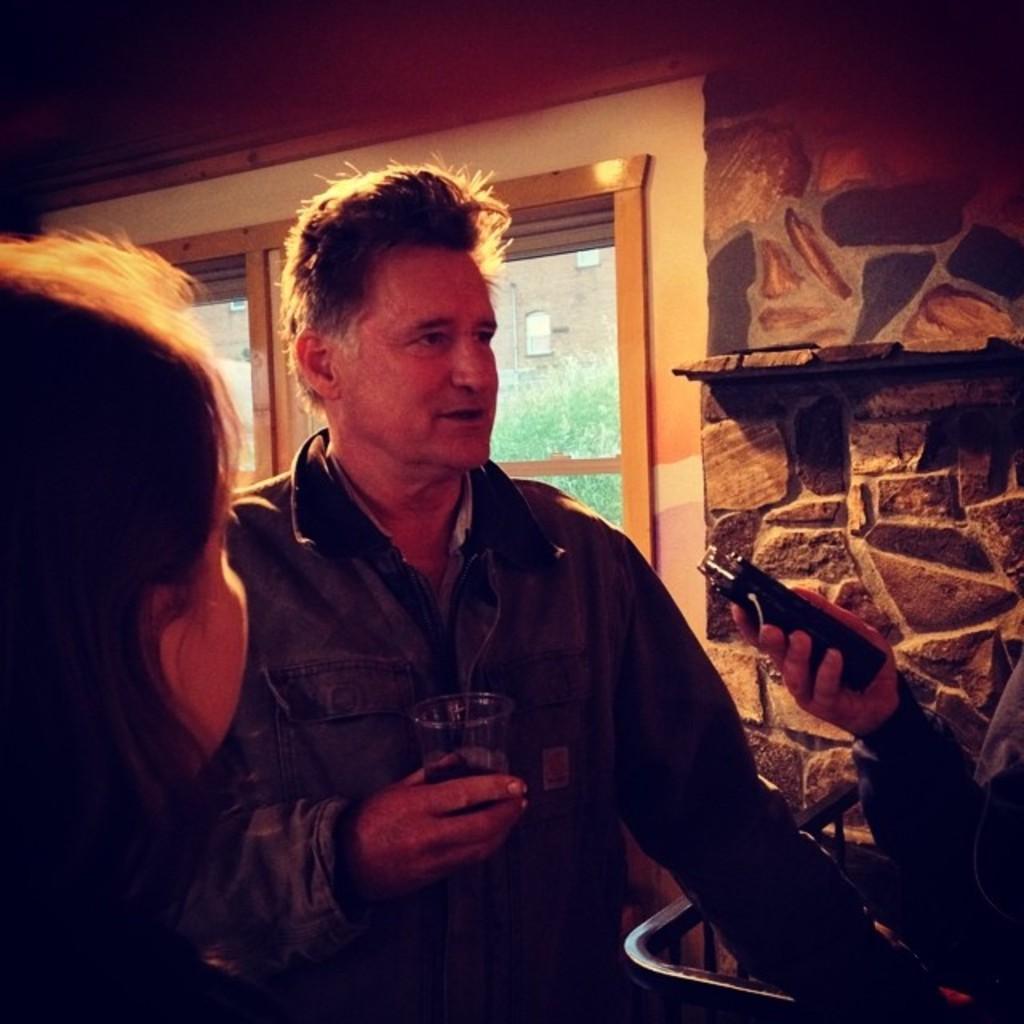Describe this image in one or two sentences. In this image I can see there are two persons and I can see window and the wall visible at the top. 